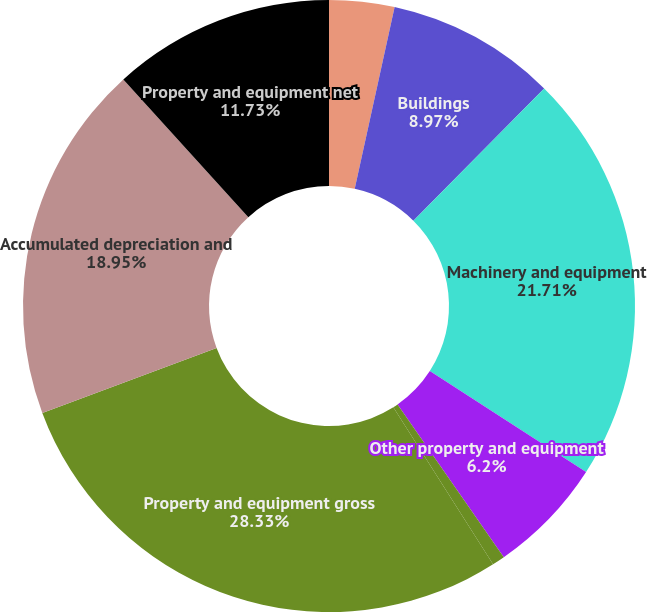Convert chart to OTSL. <chart><loc_0><loc_0><loc_500><loc_500><pie_chart><fcel>Land and improvements<fcel>Buildings<fcel>Machinery and equipment<fcel>Other property and equipment<fcel>Construction-in-progress<fcel>Property and equipment gross<fcel>Accumulated depreciation and<fcel>Property and equipment net<nl><fcel>3.44%<fcel>8.97%<fcel>21.71%<fcel>6.2%<fcel>0.67%<fcel>28.32%<fcel>18.95%<fcel>11.73%<nl></chart> 